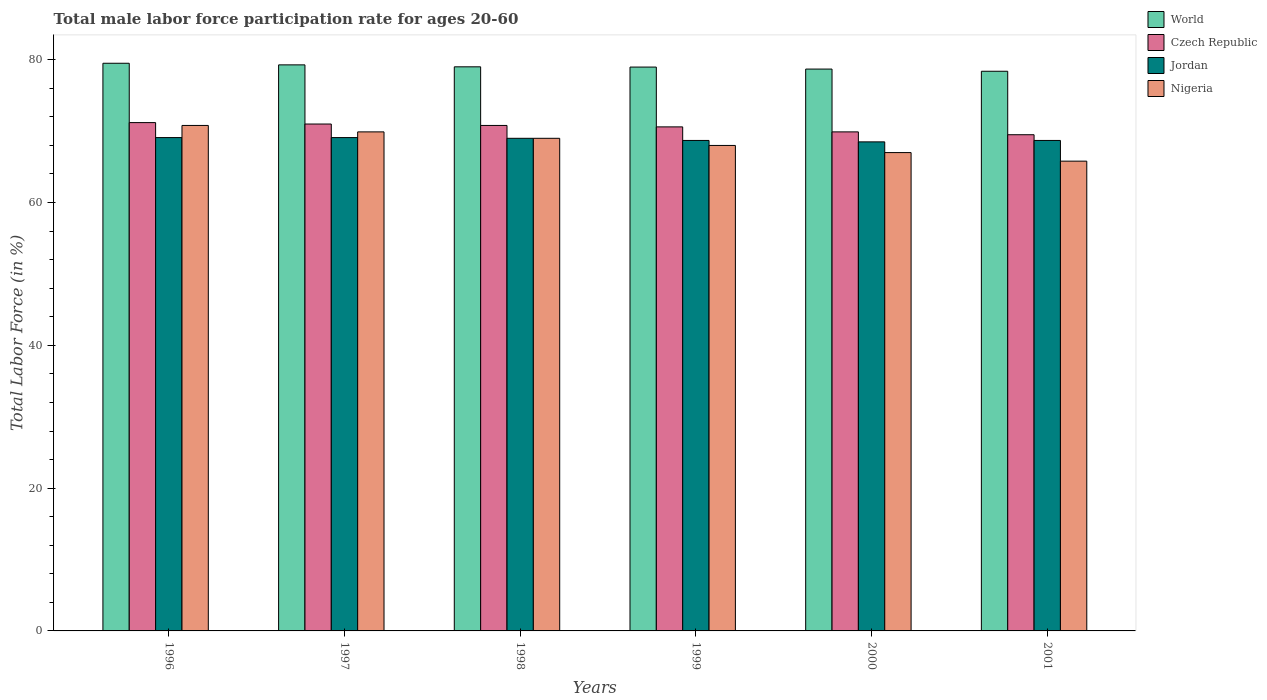Are the number of bars per tick equal to the number of legend labels?
Your answer should be very brief. Yes. How many bars are there on the 5th tick from the right?
Make the answer very short. 4. What is the label of the 6th group of bars from the left?
Your response must be concise. 2001. What is the male labor force participation rate in Jordan in 2001?
Offer a very short reply. 68.7. Across all years, what is the maximum male labor force participation rate in Czech Republic?
Ensure brevity in your answer.  71.2. Across all years, what is the minimum male labor force participation rate in Czech Republic?
Give a very brief answer. 69.5. In which year was the male labor force participation rate in Nigeria minimum?
Make the answer very short. 2001. What is the total male labor force participation rate in Czech Republic in the graph?
Make the answer very short. 423. What is the difference between the male labor force participation rate in Czech Republic in 1998 and that in 1999?
Keep it short and to the point. 0.2. What is the difference between the male labor force participation rate in Jordan in 1998 and the male labor force participation rate in World in 1999?
Provide a short and direct response. -9.98. What is the average male labor force participation rate in Jordan per year?
Make the answer very short. 68.85. In the year 1998, what is the difference between the male labor force participation rate in Jordan and male labor force participation rate in Nigeria?
Offer a terse response. 0. In how many years, is the male labor force participation rate in Czech Republic greater than 32 %?
Offer a very short reply. 6. What is the ratio of the male labor force participation rate in World in 1998 to that in 2001?
Provide a short and direct response. 1.01. Is the male labor force participation rate in World in 1998 less than that in 1999?
Provide a succinct answer. No. What is the difference between the highest and the second highest male labor force participation rate in Nigeria?
Provide a succinct answer. 0.9. What is the difference between the highest and the lowest male labor force participation rate in World?
Provide a short and direct response. 1.12. What does the 3rd bar from the right in 1998 represents?
Give a very brief answer. Czech Republic. How many bars are there?
Your answer should be very brief. 24. How many years are there in the graph?
Ensure brevity in your answer.  6. What is the difference between two consecutive major ticks on the Y-axis?
Provide a succinct answer. 20. Are the values on the major ticks of Y-axis written in scientific E-notation?
Provide a short and direct response. No. Does the graph contain grids?
Ensure brevity in your answer.  No. How many legend labels are there?
Ensure brevity in your answer.  4. How are the legend labels stacked?
Provide a succinct answer. Vertical. What is the title of the graph?
Ensure brevity in your answer.  Total male labor force participation rate for ages 20-60. Does "Albania" appear as one of the legend labels in the graph?
Your response must be concise. No. What is the label or title of the X-axis?
Ensure brevity in your answer.  Years. What is the Total Labor Force (in %) in World in 1996?
Keep it short and to the point. 79.51. What is the Total Labor Force (in %) of Czech Republic in 1996?
Offer a terse response. 71.2. What is the Total Labor Force (in %) of Jordan in 1996?
Give a very brief answer. 69.1. What is the Total Labor Force (in %) in Nigeria in 1996?
Make the answer very short. 70.8. What is the Total Labor Force (in %) of World in 1997?
Your response must be concise. 79.29. What is the Total Labor Force (in %) of Czech Republic in 1997?
Keep it short and to the point. 71. What is the Total Labor Force (in %) in Jordan in 1997?
Provide a succinct answer. 69.1. What is the Total Labor Force (in %) of Nigeria in 1997?
Make the answer very short. 69.9. What is the Total Labor Force (in %) of World in 1998?
Offer a terse response. 79.01. What is the Total Labor Force (in %) in Czech Republic in 1998?
Your response must be concise. 70.8. What is the Total Labor Force (in %) in Jordan in 1998?
Keep it short and to the point. 69. What is the Total Labor Force (in %) in Nigeria in 1998?
Your answer should be compact. 69. What is the Total Labor Force (in %) of World in 1999?
Your response must be concise. 78.98. What is the Total Labor Force (in %) of Czech Republic in 1999?
Provide a succinct answer. 70.6. What is the Total Labor Force (in %) of Jordan in 1999?
Ensure brevity in your answer.  68.7. What is the Total Labor Force (in %) of World in 2000?
Offer a very short reply. 78.7. What is the Total Labor Force (in %) of Czech Republic in 2000?
Ensure brevity in your answer.  69.9. What is the Total Labor Force (in %) in Jordan in 2000?
Give a very brief answer. 68.5. What is the Total Labor Force (in %) in World in 2001?
Provide a short and direct response. 78.39. What is the Total Labor Force (in %) of Czech Republic in 2001?
Ensure brevity in your answer.  69.5. What is the Total Labor Force (in %) in Jordan in 2001?
Ensure brevity in your answer.  68.7. What is the Total Labor Force (in %) of Nigeria in 2001?
Your response must be concise. 65.8. Across all years, what is the maximum Total Labor Force (in %) of World?
Give a very brief answer. 79.51. Across all years, what is the maximum Total Labor Force (in %) in Czech Republic?
Your answer should be compact. 71.2. Across all years, what is the maximum Total Labor Force (in %) in Jordan?
Give a very brief answer. 69.1. Across all years, what is the maximum Total Labor Force (in %) of Nigeria?
Make the answer very short. 70.8. Across all years, what is the minimum Total Labor Force (in %) of World?
Ensure brevity in your answer.  78.39. Across all years, what is the minimum Total Labor Force (in %) of Czech Republic?
Make the answer very short. 69.5. Across all years, what is the minimum Total Labor Force (in %) of Jordan?
Your answer should be compact. 68.5. Across all years, what is the minimum Total Labor Force (in %) of Nigeria?
Give a very brief answer. 65.8. What is the total Total Labor Force (in %) of World in the graph?
Ensure brevity in your answer.  473.88. What is the total Total Labor Force (in %) in Czech Republic in the graph?
Ensure brevity in your answer.  423. What is the total Total Labor Force (in %) of Jordan in the graph?
Your answer should be compact. 413.1. What is the total Total Labor Force (in %) in Nigeria in the graph?
Your response must be concise. 410.5. What is the difference between the Total Labor Force (in %) of World in 1996 and that in 1997?
Keep it short and to the point. 0.23. What is the difference between the Total Labor Force (in %) of Czech Republic in 1996 and that in 1997?
Offer a terse response. 0.2. What is the difference between the Total Labor Force (in %) in Jordan in 1996 and that in 1997?
Offer a terse response. 0. What is the difference between the Total Labor Force (in %) of World in 1996 and that in 1998?
Make the answer very short. 0.5. What is the difference between the Total Labor Force (in %) of Jordan in 1996 and that in 1998?
Your answer should be very brief. 0.1. What is the difference between the Total Labor Force (in %) in Nigeria in 1996 and that in 1998?
Offer a very short reply. 1.8. What is the difference between the Total Labor Force (in %) in World in 1996 and that in 1999?
Your response must be concise. 0.53. What is the difference between the Total Labor Force (in %) of Nigeria in 1996 and that in 1999?
Your response must be concise. 2.8. What is the difference between the Total Labor Force (in %) of World in 1996 and that in 2000?
Your response must be concise. 0.81. What is the difference between the Total Labor Force (in %) in Czech Republic in 1996 and that in 2000?
Give a very brief answer. 1.3. What is the difference between the Total Labor Force (in %) in World in 1996 and that in 2001?
Ensure brevity in your answer.  1.12. What is the difference between the Total Labor Force (in %) of Nigeria in 1996 and that in 2001?
Make the answer very short. 5. What is the difference between the Total Labor Force (in %) in World in 1997 and that in 1998?
Your answer should be compact. 0.27. What is the difference between the Total Labor Force (in %) in Czech Republic in 1997 and that in 1998?
Make the answer very short. 0.2. What is the difference between the Total Labor Force (in %) in Nigeria in 1997 and that in 1998?
Your response must be concise. 0.9. What is the difference between the Total Labor Force (in %) in World in 1997 and that in 1999?
Provide a short and direct response. 0.31. What is the difference between the Total Labor Force (in %) of Jordan in 1997 and that in 1999?
Make the answer very short. 0.4. What is the difference between the Total Labor Force (in %) in Nigeria in 1997 and that in 1999?
Give a very brief answer. 1.9. What is the difference between the Total Labor Force (in %) of World in 1997 and that in 2000?
Offer a very short reply. 0.59. What is the difference between the Total Labor Force (in %) in Jordan in 1997 and that in 2000?
Offer a terse response. 0.6. What is the difference between the Total Labor Force (in %) in Nigeria in 1997 and that in 2000?
Provide a succinct answer. 2.9. What is the difference between the Total Labor Force (in %) in World in 1997 and that in 2001?
Ensure brevity in your answer.  0.89. What is the difference between the Total Labor Force (in %) in Czech Republic in 1997 and that in 2001?
Offer a very short reply. 1.5. What is the difference between the Total Labor Force (in %) of Jordan in 1997 and that in 2001?
Make the answer very short. 0.4. What is the difference between the Total Labor Force (in %) of Nigeria in 1997 and that in 2001?
Your response must be concise. 4.1. What is the difference between the Total Labor Force (in %) in World in 1998 and that in 1999?
Offer a terse response. 0.04. What is the difference between the Total Labor Force (in %) of World in 1998 and that in 2000?
Ensure brevity in your answer.  0.32. What is the difference between the Total Labor Force (in %) of Czech Republic in 1998 and that in 2000?
Ensure brevity in your answer.  0.9. What is the difference between the Total Labor Force (in %) of Nigeria in 1998 and that in 2000?
Provide a short and direct response. 2. What is the difference between the Total Labor Force (in %) in World in 1998 and that in 2001?
Give a very brief answer. 0.62. What is the difference between the Total Labor Force (in %) of Czech Republic in 1998 and that in 2001?
Give a very brief answer. 1.3. What is the difference between the Total Labor Force (in %) in Jordan in 1998 and that in 2001?
Provide a short and direct response. 0.3. What is the difference between the Total Labor Force (in %) of Nigeria in 1998 and that in 2001?
Provide a short and direct response. 3.2. What is the difference between the Total Labor Force (in %) of World in 1999 and that in 2000?
Provide a short and direct response. 0.28. What is the difference between the Total Labor Force (in %) of Czech Republic in 1999 and that in 2000?
Give a very brief answer. 0.7. What is the difference between the Total Labor Force (in %) of World in 1999 and that in 2001?
Make the answer very short. 0.59. What is the difference between the Total Labor Force (in %) of Czech Republic in 1999 and that in 2001?
Make the answer very short. 1.1. What is the difference between the Total Labor Force (in %) in Jordan in 1999 and that in 2001?
Offer a terse response. 0. What is the difference between the Total Labor Force (in %) of World in 2000 and that in 2001?
Provide a short and direct response. 0.31. What is the difference between the Total Labor Force (in %) in Jordan in 2000 and that in 2001?
Your answer should be very brief. -0.2. What is the difference between the Total Labor Force (in %) in World in 1996 and the Total Labor Force (in %) in Czech Republic in 1997?
Provide a short and direct response. 8.51. What is the difference between the Total Labor Force (in %) of World in 1996 and the Total Labor Force (in %) of Jordan in 1997?
Provide a short and direct response. 10.41. What is the difference between the Total Labor Force (in %) of World in 1996 and the Total Labor Force (in %) of Nigeria in 1997?
Provide a short and direct response. 9.61. What is the difference between the Total Labor Force (in %) in Czech Republic in 1996 and the Total Labor Force (in %) in Jordan in 1997?
Your answer should be compact. 2.1. What is the difference between the Total Labor Force (in %) of Czech Republic in 1996 and the Total Labor Force (in %) of Nigeria in 1997?
Your answer should be compact. 1.3. What is the difference between the Total Labor Force (in %) of World in 1996 and the Total Labor Force (in %) of Czech Republic in 1998?
Your response must be concise. 8.71. What is the difference between the Total Labor Force (in %) of World in 1996 and the Total Labor Force (in %) of Jordan in 1998?
Your answer should be compact. 10.51. What is the difference between the Total Labor Force (in %) in World in 1996 and the Total Labor Force (in %) in Nigeria in 1998?
Keep it short and to the point. 10.51. What is the difference between the Total Labor Force (in %) in Czech Republic in 1996 and the Total Labor Force (in %) in Jordan in 1998?
Provide a short and direct response. 2.2. What is the difference between the Total Labor Force (in %) of Czech Republic in 1996 and the Total Labor Force (in %) of Nigeria in 1998?
Provide a succinct answer. 2.2. What is the difference between the Total Labor Force (in %) in World in 1996 and the Total Labor Force (in %) in Czech Republic in 1999?
Ensure brevity in your answer.  8.91. What is the difference between the Total Labor Force (in %) in World in 1996 and the Total Labor Force (in %) in Jordan in 1999?
Your answer should be very brief. 10.81. What is the difference between the Total Labor Force (in %) in World in 1996 and the Total Labor Force (in %) in Nigeria in 1999?
Your response must be concise. 11.51. What is the difference between the Total Labor Force (in %) of Czech Republic in 1996 and the Total Labor Force (in %) of Jordan in 1999?
Your response must be concise. 2.5. What is the difference between the Total Labor Force (in %) in Czech Republic in 1996 and the Total Labor Force (in %) in Nigeria in 1999?
Your answer should be compact. 3.2. What is the difference between the Total Labor Force (in %) of World in 1996 and the Total Labor Force (in %) of Czech Republic in 2000?
Your answer should be compact. 9.61. What is the difference between the Total Labor Force (in %) of World in 1996 and the Total Labor Force (in %) of Jordan in 2000?
Your answer should be very brief. 11.01. What is the difference between the Total Labor Force (in %) in World in 1996 and the Total Labor Force (in %) in Nigeria in 2000?
Provide a short and direct response. 12.51. What is the difference between the Total Labor Force (in %) of Czech Republic in 1996 and the Total Labor Force (in %) of Nigeria in 2000?
Provide a short and direct response. 4.2. What is the difference between the Total Labor Force (in %) in Jordan in 1996 and the Total Labor Force (in %) in Nigeria in 2000?
Keep it short and to the point. 2.1. What is the difference between the Total Labor Force (in %) of World in 1996 and the Total Labor Force (in %) of Czech Republic in 2001?
Ensure brevity in your answer.  10.01. What is the difference between the Total Labor Force (in %) in World in 1996 and the Total Labor Force (in %) in Jordan in 2001?
Your answer should be very brief. 10.81. What is the difference between the Total Labor Force (in %) of World in 1996 and the Total Labor Force (in %) of Nigeria in 2001?
Your answer should be compact. 13.71. What is the difference between the Total Labor Force (in %) in Czech Republic in 1996 and the Total Labor Force (in %) in Jordan in 2001?
Give a very brief answer. 2.5. What is the difference between the Total Labor Force (in %) of Jordan in 1996 and the Total Labor Force (in %) of Nigeria in 2001?
Offer a very short reply. 3.3. What is the difference between the Total Labor Force (in %) in World in 1997 and the Total Labor Force (in %) in Czech Republic in 1998?
Give a very brief answer. 8.49. What is the difference between the Total Labor Force (in %) of World in 1997 and the Total Labor Force (in %) of Jordan in 1998?
Your response must be concise. 10.29. What is the difference between the Total Labor Force (in %) in World in 1997 and the Total Labor Force (in %) in Nigeria in 1998?
Your answer should be very brief. 10.29. What is the difference between the Total Labor Force (in %) in Czech Republic in 1997 and the Total Labor Force (in %) in Jordan in 1998?
Your response must be concise. 2. What is the difference between the Total Labor Force (in %) in World in 1997 and the Total Labor Force (in %) in Czech Republic in 1999?
Provide a short and direct response. 8.69. What is the difference between the Total Labor Force (in %) of World in 1997 and the Total Labor Force (in %) of Jordan in 1999?
Provide a succinct answer. 10.59. What is the difference between the Total Labor Force (in %) in World in 1997 and the Total Labor Force (in %) in Nigeria in 1999?
Your response must be concise. 11.29. What is the difference between the Total Labor Force (in %) in Czech Republic in 1997 and the Total Labor Force (in %) in Jordan in 1999?
Make the answer very short. 2.3. What is the difference between the Total Labor Force (in %) in Jordan in 1997 and the Total Labor Force (in %) in Nigeria in 1999?
Your response must be concise. 1.1. What is the difference between the Total Labor Force (in %) in World in 1997 and the Total Labor Force (in %) in Czech Republic in 2000?
Give a very brief answer. 9.39. What is the difference between the Total Labor Force (in %) in World in 1997 and the Total Labor Force (in %) in Jordan in 2000?
Offer a terse response. 10.79. What is the difference between the Total Labor Force (in %) of World in 1997 and the Total Labor Force (in %) of Nigeria in 2000?
Give a very brief answer. 12.29. What is the difference between the Total Labor Force (in %) of Czech Republic in 1997 and the Total Labor Force (in %) of Jordan in 2000?
Offer a terse response. 2.5. What is the difference between the Total Labor Force (in %) in Jordan in 1997 and the Total Labor Force (in %) in Nigeria in 2000?
Offer a terse response. 2.1. What is the difference between the Total Labor Force (in %) of World in 1997 and the Total Labor Force (in %) of Czech Republic in 2001?
Make the answer very short. 9.79. What is the difference between the Total Labor Force (in %) of World in 1997 and the Total Labor Force (in %) of Jordan in 2001?
Offer a terse response. 10.59. What is the difference between the Total Labor Force (in %) of World in 1997 and the Total Labor Force (in %) of Nigeria in 2001?
Your response must be concise. 13.49. What is the difference between the Total Labor Force (in %) in Czech Republic in 1997 and the Total Labor Force (in %) in Jordan in 2001?
Your answer should be very brief. 2.3. What is the difference between the Total Labor Force (in %) in Jordan in 1997 and the Total Labor Force (in %) in Nigeria in 2001?
Provide a short and direct response. 3.3. What is the difference between the Total Labor Force (in %) of World in 1998 and the Total Labor Force (in %) of Czech Republic in 1999?
Your answer should be compact. 8.41. What is the difference between the Total Labor Force (in %) in World in 1998 and the Total Labor Force (in %) in Jordan in 1999?
Offer a very short reply. 10.31. What is the difference between the Total Labor Force (in %) of World in 1998 and the Total Labor Force (in %) of Nigeria in 1999?
Offer a very short reply. 11.01. What is the difference between the Total Labor Force (in %) of Czech Republic in 1998 and the Total Labor Force (in %) of Jordan in 1999?
Provide a succinct answer. 2.1. What is the difference between the Total Labor Force (in %) in Czech Republic in 1998 and the Total Labor Force (in %) in Nigeria in 1999?
Offer a very short reply. 2.8. What is the difference between the Total Labor Force (in %) in World in 1998 and the Total Labor Force (in %) in Czech Republic in 2000?
Your response must be concise. 9.11. What is the difference between the Total Labor Force (in %) in World in 1998 and the Total Labor Force (in %) in Jordan in 2000?
Your response must be concise. 10.51. What is the difference between the Total Labor Force (in %) in World in 1998 and the Total Labor Force (in %) in Nigeria in 2000?
Provide a succinct answer. 12.01. What is the difference between the Total Labor Force (in %) in Czech Republic in 1998 and the Total Labor Force (in %) in Nigeria in 2000?
Your answer should be compact. 3.8. What is the difference between the Total Labor Force (in %) of World in 1998 and the Total Labor Force (in %) of Czech Republic in 2001?
Ensure brevity in your answer.  9.51. What is the difference between the Total Labor Force (in %) of World in 1998 and the Total Labor Force (in %) of Jordan in 2001?
Your answer should be very brief. 10.31. What is the difference between the Total Labor Force (in %) in World in 1998 and the Total Labor Force (in %) in Nigeria in 2001?
Your answer should be very brief. 13.21. What is the difference between the Total Labor Force (in %) in Czech Republic in 1998 and the Total Labor Force (in %) in Jordan in 2001?
Make the answer very short. 2.1. What is the difference between the Total Labor Force (in %) in Jordan in 1998 and the Total Labor Force (in %) in Nigeria in 2001?
Offer a very short reply. 3.2. What is the difference between the Total Labor Force (in %) in World in 1999 and the Total Labor Force (in %) in Czech Republic in 2000?
Make the answer very short. 9.08. What is the difference between the Total Labor Force (in %) in World in 1999 and the Total Labor Force (in %) in Jordan in 2000?
Give a very brief answer. 10.48. What is the difference between the Total Labor Force (in %) of World in 1999 and the Total Labor Force (in %) of Nigeria in 2000?
Ensure brevity in your answer.  11.98. What is the difference between the Total Labor Force (in %) of Czech Republic in 1999 and the Total Labor Force (in %) of Jordan in 2000?
Offer a terse response. 2.1. What is the difference between the Total Labor Force (in %) in Jordan in 1999 and the Total Labor Force (in %) in Nigeria in 2000?
Make the answer very short. 1.7. What is the difference between the Total Labor Force (in %) of World in 1999 and the Total Labor Force (in %) of Czech Republic in 2001?
Give a very brief answer. 9.48. What is the difference between the Total Labor Force (in %) of World in 1999 and the Total Labor Force (in %) of Jordan in 2001?
Your answer should be very brief. 10.28. What is the difference between the Total Labor Force (in %) of World in 1999 and the Total Labor Force (in %) of Nigeria in 2001?
Offer a terse response. 13.18. What is the difference between the Total Labor Force (in %) of Czech Republic in 1999 and the Total Labor Force (in %) of Nigeria in 2001?
Provide a succinct answer. 4.8. What is the difference between the Total Labor Force (in %) of Jordan in 1999 and the Total Labor Force (in %) of Nigeria in 2001?
Offer a terse response. 2.9. What is the difference between the Total Labor Force (in %) in World in 2000 and the Total Labor Force (in %) in Czech Republic in 2001?
Your response must be concise. 9.2. What is the difference between the Total Labor Force (in %) in World in 2000 and the Total Labor Force (in %) in Jordan in 2001?
Offer a very short reply. 10. What is the difference between the Total Labor Force (in %) in World in 2000 and the Total Labor Force (in %) in Nigeria in 2001?
Provide a short and direct response. 12.9. What is the difference between the Total Labor Force (in %) of Czech Republic in 2000 and the Total Labor Force (in %) of Jordan in 2001?
Your answer should be very brief. 1.2. What is the difference between the Total Labor Force (in %) of Jordan in 2000 and the Total Labor Force (in %) of Nigeria in 2001?
Provide a short and direct response. 2.7. What is the average Total Labor Force (in %) in World per year?
Your answer should be very brief. 78.98. What is the average Total Labor Force (in %) of Czech Republic per year?
Offer a terse response. 70.5. What is the average Total Labor Force (in %) of Jordan per year?
Make the answer very short. 68.85. What is the average Total Labor Force (in %) in Nigeria per year?
Offer a very short reply. 68.42. In the year 1996, what is the difference between the Total Labor Force (in %) in World and Total Labor Force (in %) in Czech Republic?
Your answer should be very brief. 8.31. In the year 1996, what is the difference between the Total Labor Force (in %) of World and Total Labor Force (in %) of Jordan?
Make the answer very short. 10.41. In the year 1996, what is the difference between the Total Labor Force (in %) in World and Total Labor Force (in %) in Nigeria?
Offer a terse response. 8.71. In the year 1997, what is the difference between the Total Labor Force (in %) of World and Total Labor Force (in %) of Czech Republic?
Your response must be concise. 8.29. In the year 1997, what is the difference between the Total Labor Force (in %) of World and Total Labor Force (in %) of Jordan?
Keep it short and to the point. 10.19. In the year 1997, what is the difference between the Total Labor Force (in %) in World and Total Labor Force (in %) in Nigeria?
Offer a very short reply. 9.39. In the year 1997, what is the difference between the Total Labor Force (in %) in Jordan and Total Labor Force (in %) in Nigeria?
Ensure brevity in your answer.  -0.8. In the year 1998, what is the difference between the Total Labor Force (in %) of World and Total Labor Force (in %) of Czech Republic?
Offer a terse response. 8.21. In the year 1998, what is the difference between the Total Labor Force (in %) in World and Total Labor Force (in %) in Jordan?
Your answer should be compact. 10.01. In the year 1998, what is the difference between the Total Labor Force (in %) of World and Total Labor Force (in %) of Nigeria?
Your answer should be compact. 10.01. In the year 1998, what is the difference between the Total Labor Force (in %) in Czech Republic and Total Labor Force (in %) in Jordan?
Ensure brevity in your answer.  1.8. In the year 1998, what is the difference between the Total Labor Force (in %) in Czech Republic and Total Labor Force (in %) in Nigeria?
Your answer should be very brief. 1.8. In the year 1999, what is the difference between the Total Labor Force (in %) of World and Total Labor Force (in %) of Czech Republic?
Provide a succinct answer. 8.38. In the year 1999, what is the difference between the Total Labor Force (in %) of World and Total Labor Force (in %) of Jordan?
Provide a short and direct response. 10.28. In the year 1999, what is the difference between the Total Labor Force (in %) of World and Total Labor Force (in %) of Nigeria?
Offer a terse response. 10.98. In the year 2000, what is the difference between the Total Labor Force (in %) in World and Total Labor Force (in %) in Czech Republic?
Provide a succinct answer. 8.8. In the year 2000, what is the difference between the Total Labor Force (in %) in World and Total Labor Force (in %) in Jordan?
Make the answer very short. 10.2. In the year 2000, what is the difference between the Total Labor Force (in %) in World and Total Labor Force (in %) in Nigeria?
Ensure brevity in your answer.  11.7. In the year 2000, what is the difference between the Total Labor Force (in %) in Czech Republic and Total Labor Force (in %) in Jordan?
Your answer should be very brief. 1.4. In the year 2000, what is the difference between the Total Labor Force (in %) in Jordan and Total Labor Force (in %) in Nigeria?
Your answer should be very brief. 1.5. In the year 2001, what is the difference between the Total Labor Force (in %) of World and Total Labor Force (in %) of Czech Republic?
Provide a short and direct response. 8.89. In the year 2001, what is the difference between the Total Labor Force (in %) in World and Total Labor Force (in %) in Jordan?
Ensure brevity in your answer.  9.69. In the year 2001, what is the difference between the Total Labor Force (in %) of World and Total Labor Force (in %) of Nigeria?
Keep it short and to the point. 12.59. In the year 2001, what is the difference between the Total Labor Force (in %) of Czech Republic and Total Labor Force (in %) of Jordan?
Your response must be concise. 0.8. In the year 2001, what is the difference between the Total Labor Force (in %) of Czech Republic and Total Labor Force (in %) of Nigeria?
Offer a very short reply. 3.7. What is the ratio of the Total Labor Force (in %) in World in 1996 to that in 1997?
Offer a very short reply. 1. What is the ratio of the Total Labor Force (in %) in Jordan in 1996 to that in 1997?
Give a very brief answer. 1. What is the ratio of the Total Labor Force (in %) of Nigeria in 1996 to that in 1997?
Your answer should be very brief. 1.01. What is the ratio of the Total Labor Force (in %) in Czech Republic in 1996 to that in 1998?
Make the answer very short. 1.01. What is the ratio of the Total Labor Force (in %) in Jordan in 1996 to that in 1998?
Make the answer very short. 1. What is the ratio of the Total Labor Force (in %) of Nigeria in 1996 to that in 1998?
Make the answer very short. 1.03. What is the ratio of the Total Labor Force (in %) in World in 1996 to that in 1999?
Give a very brief answer. 1.01. What is the ratio of the Total Labor Force (in %) of Czech Republic in 1996 to that in 1999?
Ensure brevity in your answer.  1.01. What is the ratio of the Total Labor Force (in %) in Nigeria in 1996 to that in 1999?
Your response must be concise. 1.04. What is the ratio of the Total Labor Force (in %) in World in 1996 to that in 2000?
Provide a succinct answer. 1.01. What is the ratio of the Total Labor Force (in %) in Czech Republic in 1996 to that in 2000?
Your response must be concise. 1.02. What is the ratio of the Total Labor Force (in %) in Jordan in 1996 to that in 2000?
Ensure brevity in your answer.  1.01. What is the ratio of the Total Labor Force (in %) of Nigeria in 1996 to that in 2000?
Provide a short and direct response. 1.06. What is the ratio of the Total Labor Force (in %) in World in 1996 to that in 2001?
Provide a succinct answer. 1.01. What is the ratio of the Total Labor Force (in %) of Czech Republic in 1996 to that in 2001?
Make the answer very short. 1.02. What is the ratio of the Total Labor Force (in %) of Jordan in 1996 to that in 2001?
Your response must be concise. 1.01. What is the ratio of the Total Labor Force (in %) in Nigeria in 1996 to that in 2001?
Keep it short and to the point. 1.08. What is the ratio of the Total Labor Force (in %) of Czech Republic in 1997 to that in 1998?
Provide a short and direct response. 1. What is the ratio of the Total Labor Force (in %) of Nigeria in 1997 to that in 1998?
Offer a very short reply. 1.01. What is the ratio of the Total Labor Force (in %) of World in 1997 to that in 1999?
Offer a terse response. 1. What is the ratio of the Total Labor Force (in %) of Czech Republic in 1997 to that in 1999?
Your answer should be compact. 1.01. What is the ratio of the Total Labor Force (in %) in Nigeria in 1997 to that in 1999?
Your response must be concise. 1.03. What is the ratio of the Total Labor Force (in %) in World in 1997 to that in 2000?
Offer a very short reply. 1.01. What is the ratio of the Total Labor Force (in %) in Czech Republic in 1997 to that in 2000?
Your answer should be compact. 1.02. What is the ratio of the Total Labor Force (in %) of Jordan in 1997 to that in 2000?
Make the answer very short. 1.01. What is the ratio of the Total Labor Force (in %) in Nigeria in 1997 to that in 2000?
Your response must be concise. 1.04. What is the ratio of the Total Labor Force (in %) in World in 1997 to that in 2001?
Ensure brevity in your answer.  1.01. What is the ratio of the Total Labor Force (in %) in Czech Republic in 1997 to that in 2001?
Provide a short and direct response. 1.02. What is the ratio of the Total Labor Force (in %) in Jordan in 1997 to that in 2001?
Your answer should be compact. 1.01. What is the ratio of the Total Labor Force (in %) in Nigeria in 1997 to that in 2001?
Ensure brevity in your answer.  1.06. What is the ratio of the Total Labor Force (in %) in Nigeria in 1998 to that in 1999?
Provide a short and direct response. 1.01. What is the ratio of the Total Labor Force (in %) of Czech Republic in 1998 to that in 2000?
Your response must be concise. 1.01. What is the ratio of the Total Labor Force (in %) of Jordan in 1998 to that in 2000?
Keep it short and to the point. 1.01. What is the ratio of the Total Labor Force (in %) of Nigeria in 1998 to that in 2000?
Your response must be concise. 1.03. What is the ratio of the Total Labor Force (in %) in World in 1998 to that in 2001?
Keep it short and to the point. 1.01. What is the ratio of the Total Labor Force (in %) in Czech Republic in 1998 to that in 2001?
Offer a very short reply. 1.02. What is the ratio of the Total Labor Force (in %) in Nigeria in 1998 to that in 2001?
Ensure brevity in your answer.  1.05. What is the ratio of the Total Labor Force (in %) in World in 1999 to that in 2000?
Make the answer very short. 1. What is the ratio of the Total Labor Force (in %) of Jordan in 1999 to that in 2000?
Provide a short and direct response. 1. What is the ratio of the Total Labor Force (in %) of Nigeria in 1999 to that in 2000?
Ensure brevity in your answer.  1.01. What is the ratio of the Total Labor Force (in %) in World in 1999 to that in 2001?
Offer a terse response. 1.01. What is the ratio of the Total Labor Force (in %) of Czech Republic in 1999 to that in 2001?
Your answer should be very brief. 1.02. What is the ratio of the Total Labor Force (in %) in Nigeria in 1999 to that in 2001?
Offer a very short reply. 1.03. What is the ratio of the Total Labor Force (in %) in Nigeria in 2000 to that in 2001?
Make the answer very short. 1.02. What is the difference between the highest and the second highest Total Labor Force (in %) in World?
Your response must be concise. 0.23. What is the difference between the highest and the second highest Total Labor Force (in %) in Jordan?
Your answer should be compact. 0. What is the difference between the highest and the lowest Total Labor Force (in %) in World?
Ensure brevity in your answer.  1.12. What is the difference between the highest and the lowest Total Labor Force (in %) in Czech Republic?
Keep it short and to the point. 1.7. 